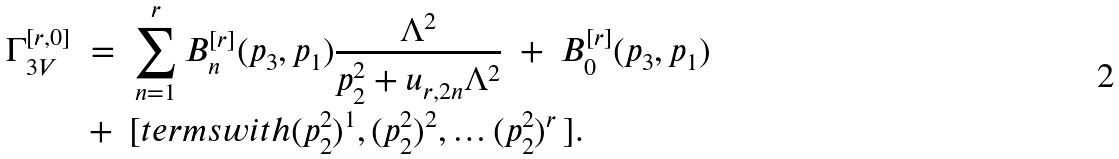Convert formula to latex. <formula><loc_0><loc_0><loc_500><loc_500>\Gamma _ { 3 V } ^ { [ r , 0 ] } \ & = \ \sum _ { n = 1 } ^ { r } B _ { n } ^ { [ r ] } ( p _ { 3 } , p _ { 1 } ) \frac { \Lambda ^ { 2 } } { p _ { 2 } ^ { 2 } + u _ { r , 2 n } \Lambda ^ { 2 } } \ + \ B _ { 0 } ^ { [ r ] } ( p _ { 3 } , p _ { 1 } ) \\ & + \ [ t e r m s w i t h ( p _ { 2 } ^ { 2 } ) ^ { 1 } , ( p _ { 2 } ^ { 2 } ) ^ { 2 } , \dots ( p _ { 2 } ^ { 2 } ) ^ { r } \, ] .</formula> 